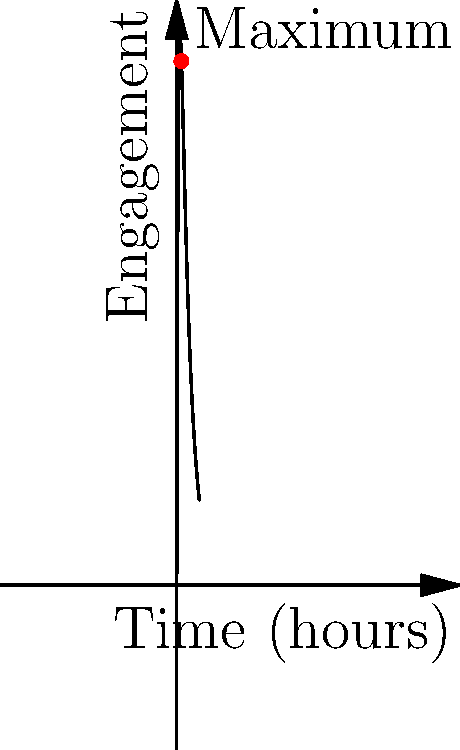A social media post promoting a new indie electronic music genre has an engagement function given by $E(t) = 1000(1-e^{-0.5t})e^{-0.1t}$, where $E$ is the number of engagements and $t$ is the time in hours since posting. At what time does the post reach its maximum engagement, and what is this maximum engagement value? To find the maximum engagement, we need to find the critical points of the function $E(t)$ by taking its derivative and setting it equal to zero.

1. First, let's calculate $E'(t)$ using the product rule:
   $E'(t) = 1000[(1-e^{-0.5t})(-0.1e^{-0.1t}) + (0.5e^{-0.5t})(e^{-0.1t})]$
   $E'(t) = 1000e^{-0.1t}[0.5e^{-0.5t} - 0.1 + 0.1e^{-0.5t}]$
   $E'(t) = 1000e^{-0.1t}[0.6e^{-0.5t} - 0.1]$

2. Set $E'(t) = 0$ and solve for $t$:
   $1000e^{-0.1t}[0.6e^{-0.5t} - 0.1] = 0$
   $0.6e^{-0.5t} - 0.1 = 0$
   $0.6e^{-0.5t} = 0.1$
   $e^{-0.5t} = \frac{1}{6}$
   $-0.5t = \ln(\frac{1}{6})$
   $t = -2\ln(\frac{1}{6}) = 2\ln(6) \approx 3.58$

3. The second derivative test confirms this is a maximum:
   $E''(t) = 1000e^{-0.1t}[-0.1(0.6e^{-0.5t} - 0.1) + (-0.3e^{-0.5t})]$
   At $t = 2\ln(6)$, $E''(t) < 0$, confirming a maximum.

4. Calculate the maximum engagement:
   $E(2\ln(6)) = 1000(1-e^{-0.5(2\ln(6))})e^{-0.1(2\ln(6))}$
   $= 1000(1-\frac{1}{6})(\frac{1}{6})^{0.2}$
   $\approx 370.4$

Therefore, the post reaches its maximum engagement at approximately 3.58 hours after posting, with about 370 engagements.
Answer: Time: $2\ln(6) \approx 3.58$ hours; Maximum engagement: $\approx 370$ 